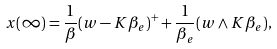Convert formula to latex. <formula><loc_0><loc_0><loc_500><loc_500>x ( \infty ) = \frac { 1 } { \beta } ( w - K \beta _ { e } ) ^ { + } + \frac { 1 } { \beta _ { e } } ( w \wedge K \beta _ { e } ) ,</formula> 